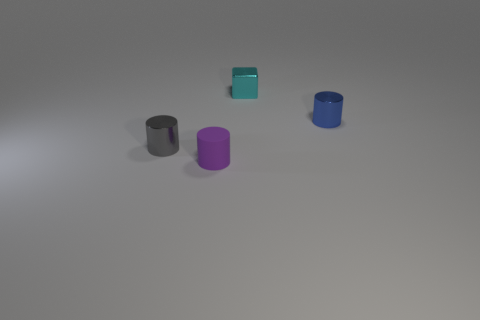What is the material of the blue thing that is the same shape as the small gray metal thing? The blue object, which shares its cylindrical shape with the small gray item, appears to be made of metal as well, given its reflective surface and consistent texture with the gray one. 